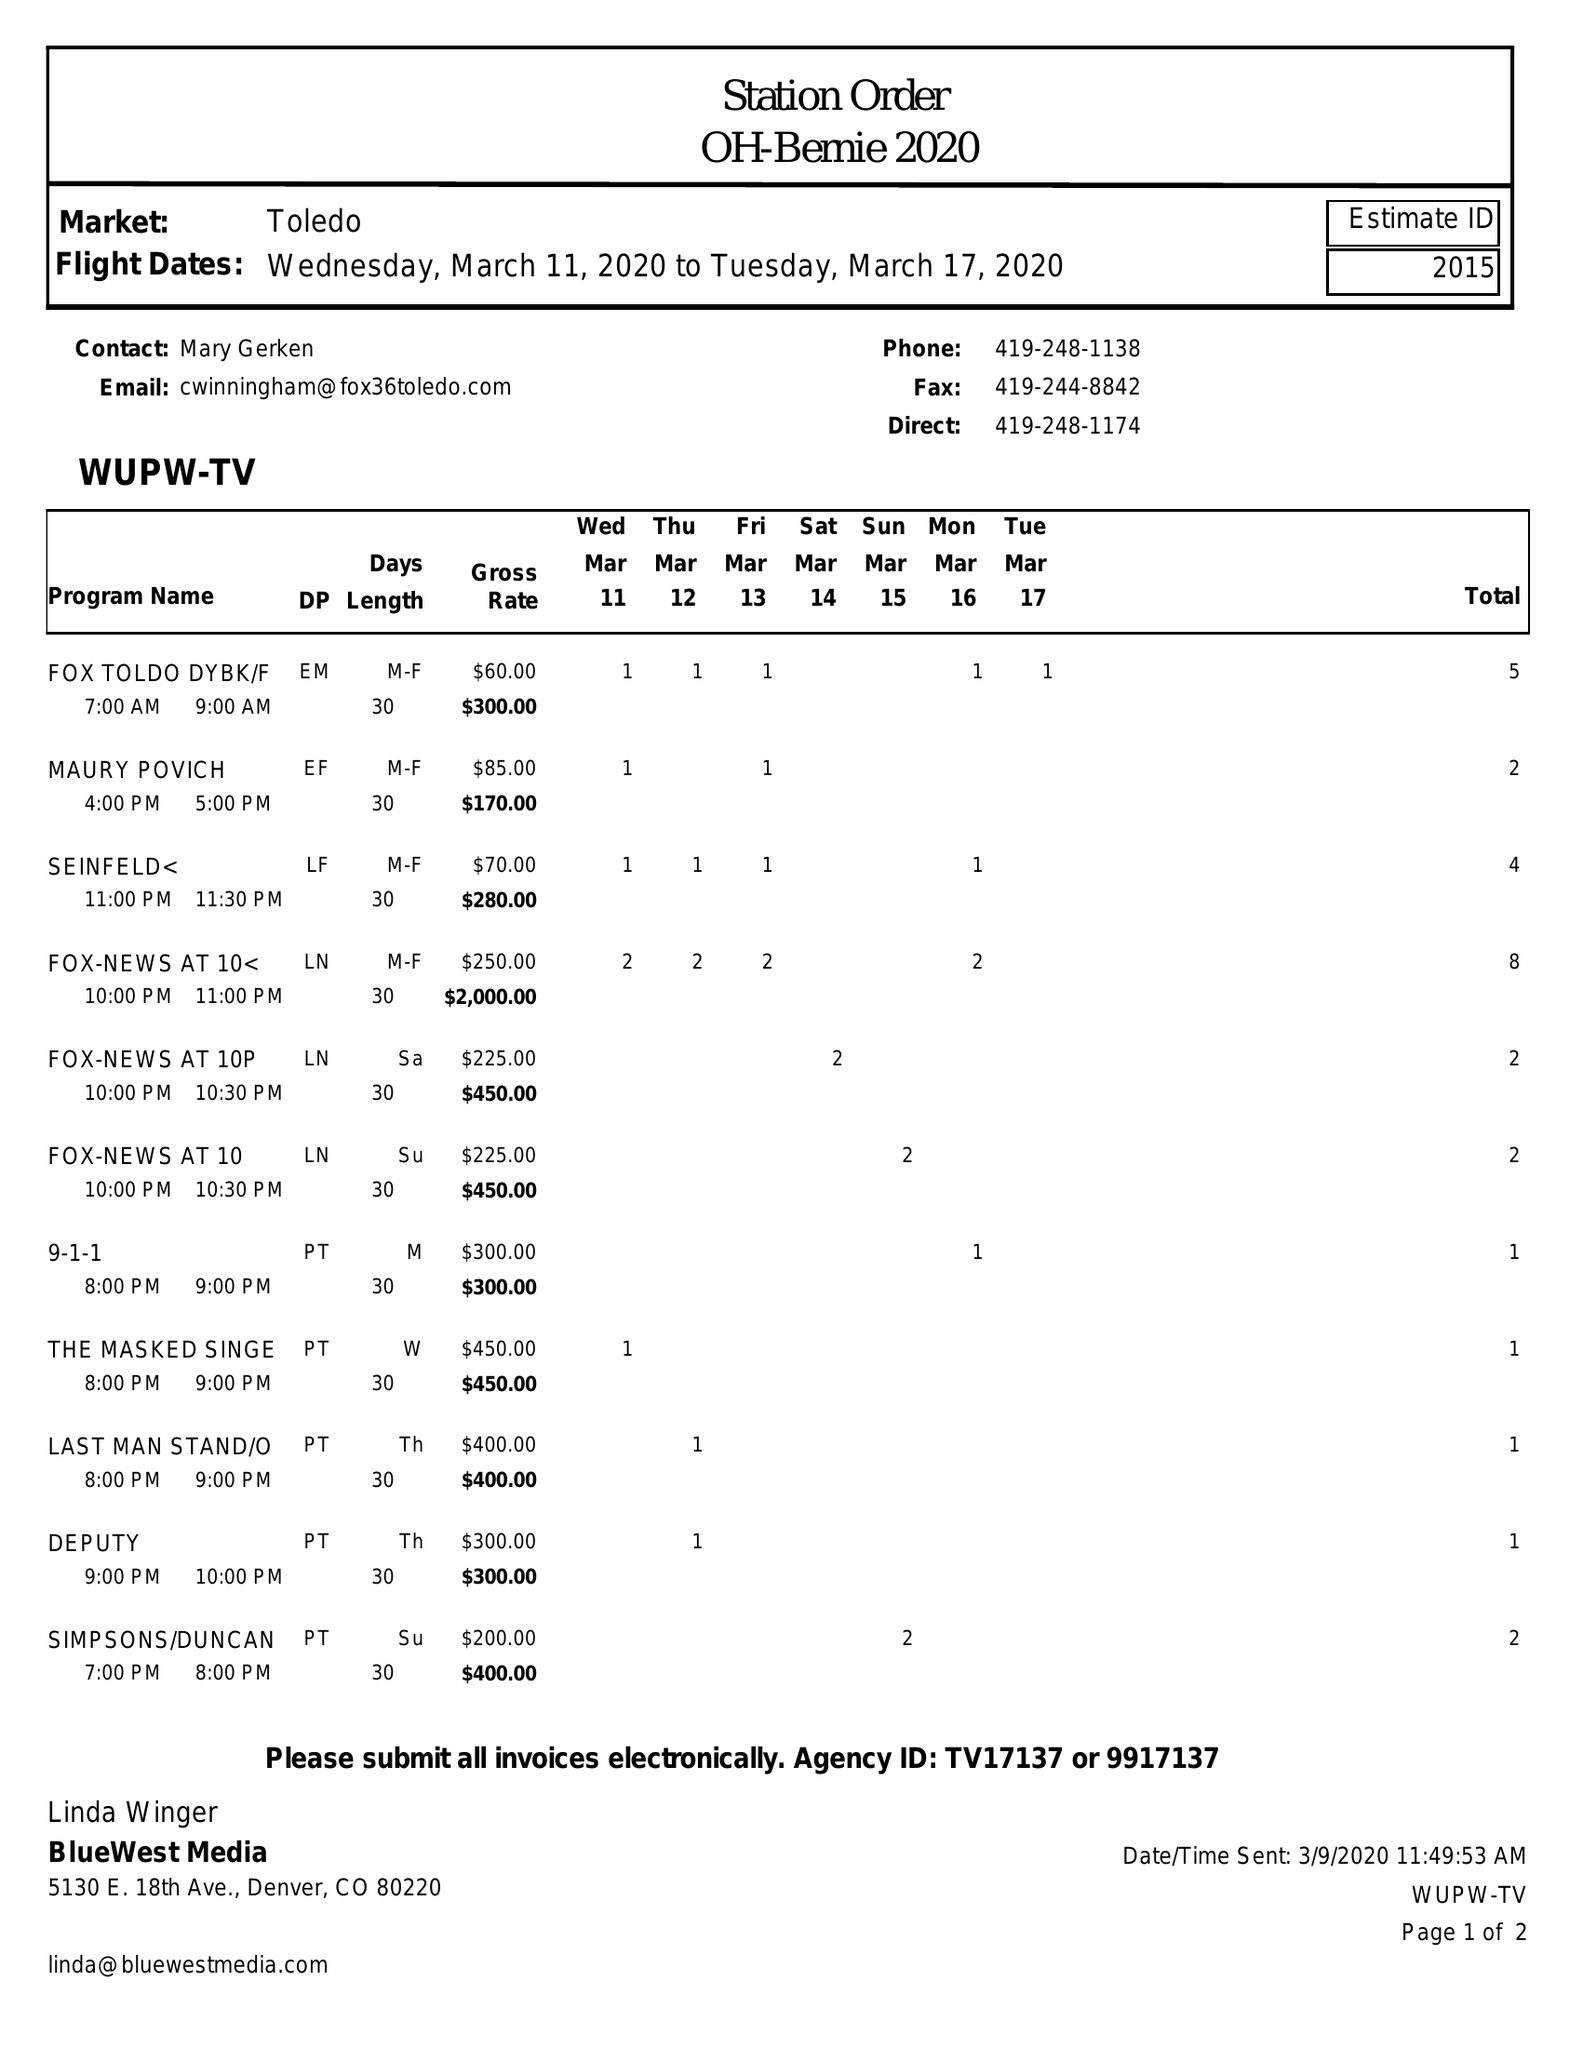What is the value for the flight_from?
Answer the question using a single word or phrase. 03/11/20 